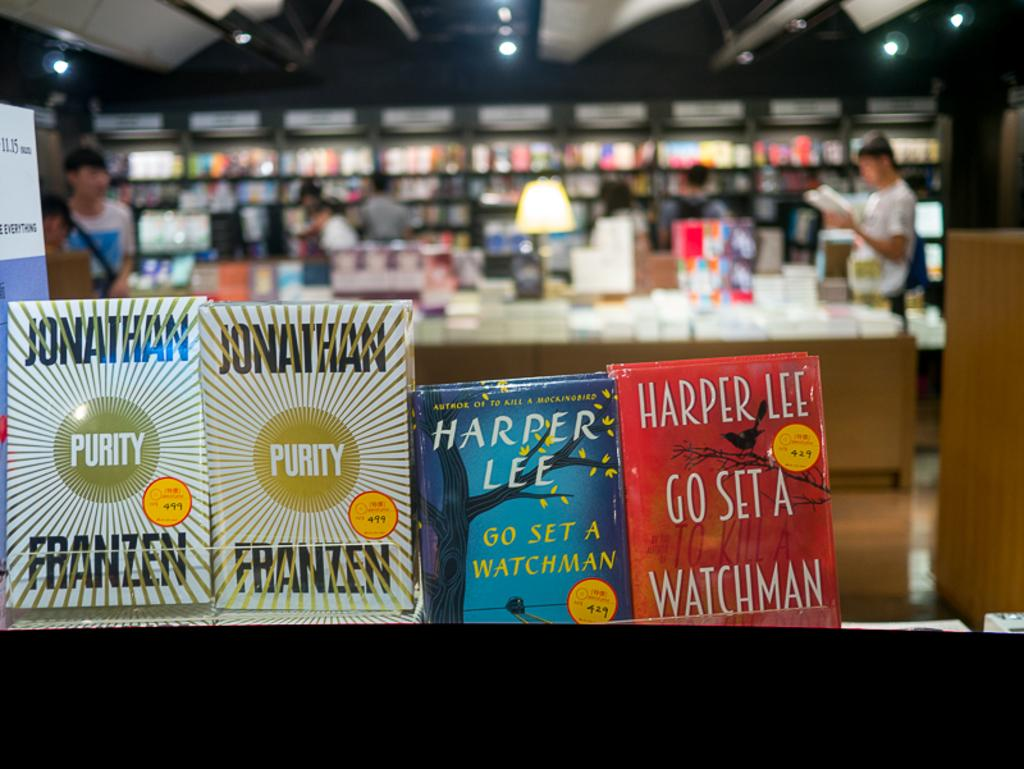<image>
Provide a brief description of the given image. Harper Lee wrote the novel "Go Set a Watchman." 